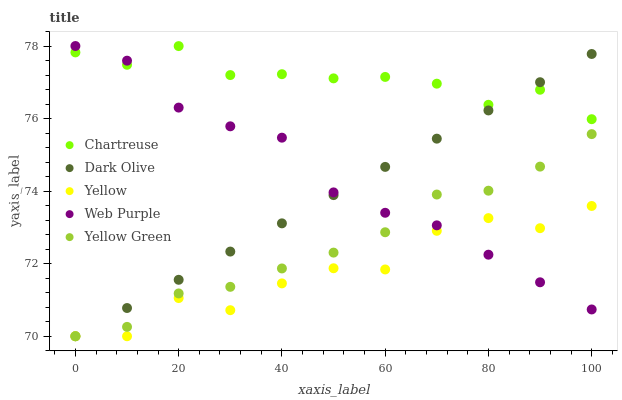Does Yellow have the minimum area under the curve?
Answer yes or no. Yes. Does Chartreuse have the maximum area under the curve?
Answer yes or no. Yes. Does Dark Olive have the minimum area under the curve?
Answer yes or no. No. Does Dark Olive have the maximum area under the curve?
Answer yes or no. No. Is Dark Olive the smoothest?
Answer yes or no. Yes. Is Yellow the roughest?
Answer yes or no. Yes. Is Web Purple the smoothest?
Answer yes or no. No. Is Web Purple the roughest?
Answer yes or no. No. Does Dark Olive have the lowest value?
Answer yes or no. Yes. Does Web Purple have the lowest value?
Answer yes or no. No. Does Web Purple have the highest value?
Answer yes or no. Yes. Does Dark Olive have the highest value?
Answer yes or no. No. Is Yellow Green less than Chartreuse?
Answer yes or no. Yes. Is Chartreuse greater than Yellow?
Answer yes or no. Yes. Does Dark Olive intersect Yellow?
Answer yes or no. Yes. Is Dark Olive less than Yellow?
Answer yes or no. No. Is Dark Olive greater than Yellow?
Answer yes or no. No. Does Yellow Green intersect Chartreuse?
Answer yes or no. No. 